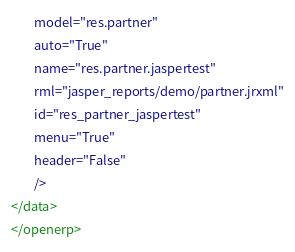<code> <loc_0><loc_0><loc_500><loc_500><_XML_>        model="res.partner"
        auto="True"
        name="res.partner.jaspertest"
        rml="jasper_reports/demo/partner.jrxml"
        id="res_partner_jaspertest" 
        menu="True"
        header="False"
        />
</data>
</openerp>
</code> 